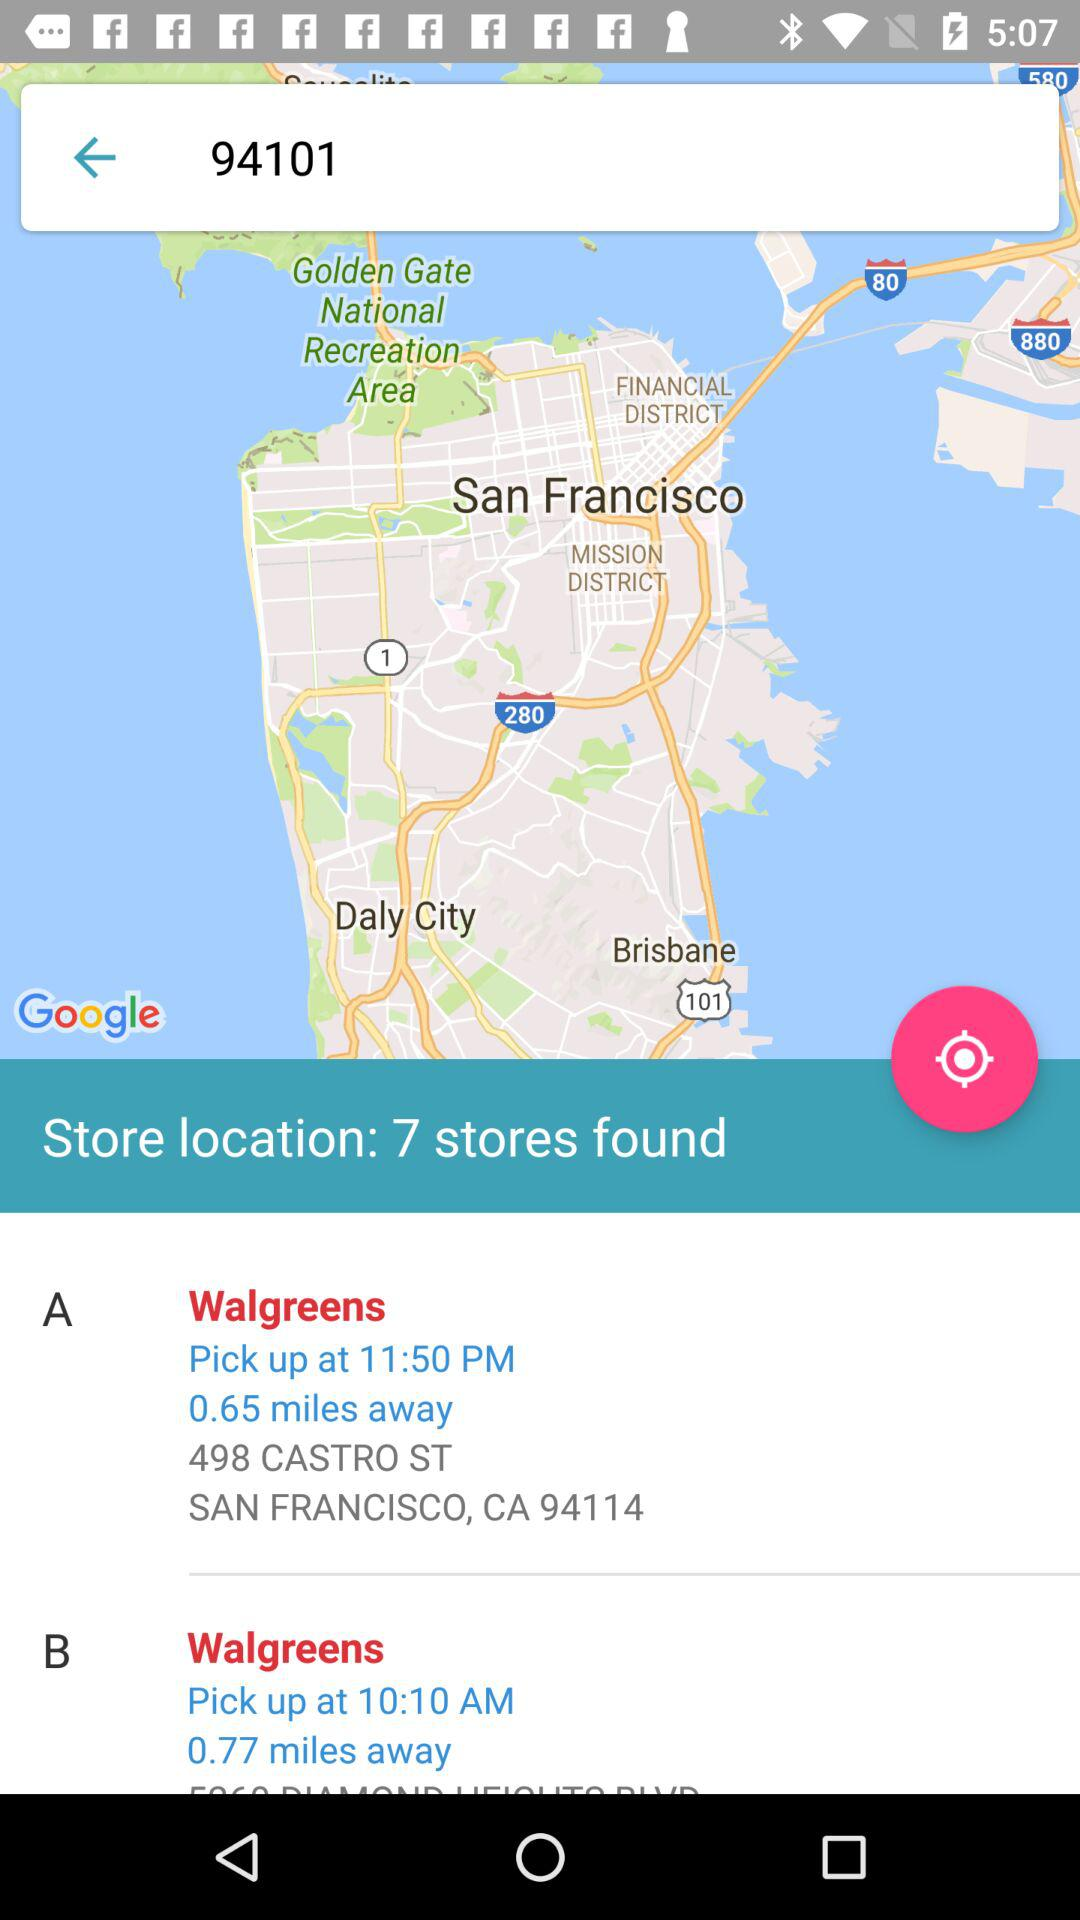What pickup time is given for Walgreens-A? The pickup time is 11:50 PM. 